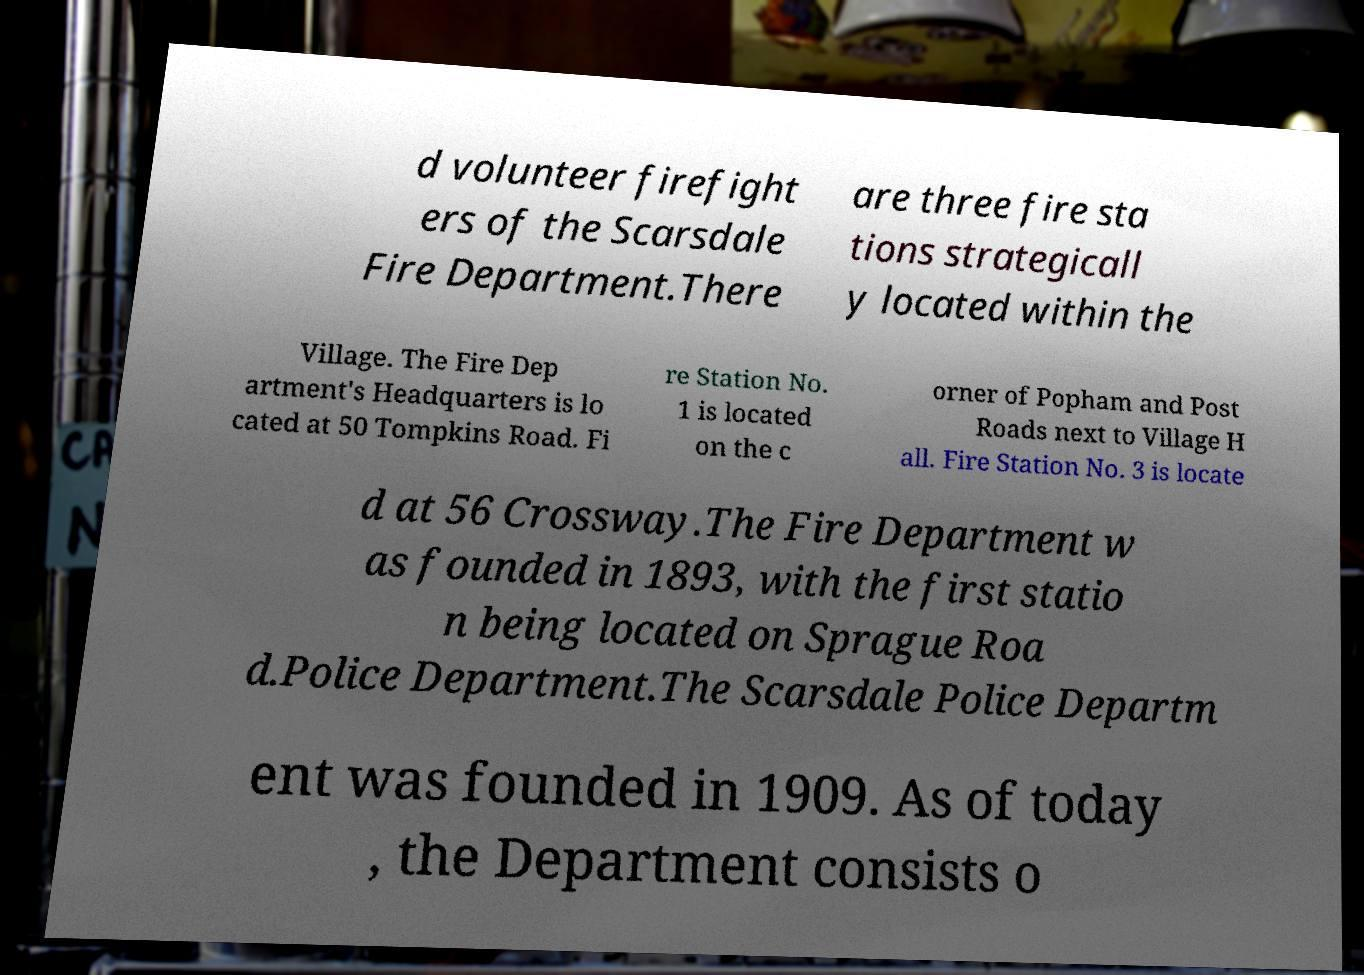What messages or text are displayed in this image? I need them in a readable, typed format. d volunteer firefight ers of the Scarsdale Fire Department.There are three fire sta tions strategicall y located within the Village. The Fire Dep artment's Headquarters is lo cated at 50 Tompkins Road. Fi re Station No. 1 is located on the c orner of Popham and Post Roads next to Village H all. Fire Station No. 3 is locate d at 56 Crossway.The Fire Department w as founded in 1893, with the first statio n being located on Sprague Roa d.Police Department.The Scarsdale Police Departm ent was founded in 1909. As of today , the Department consists o 